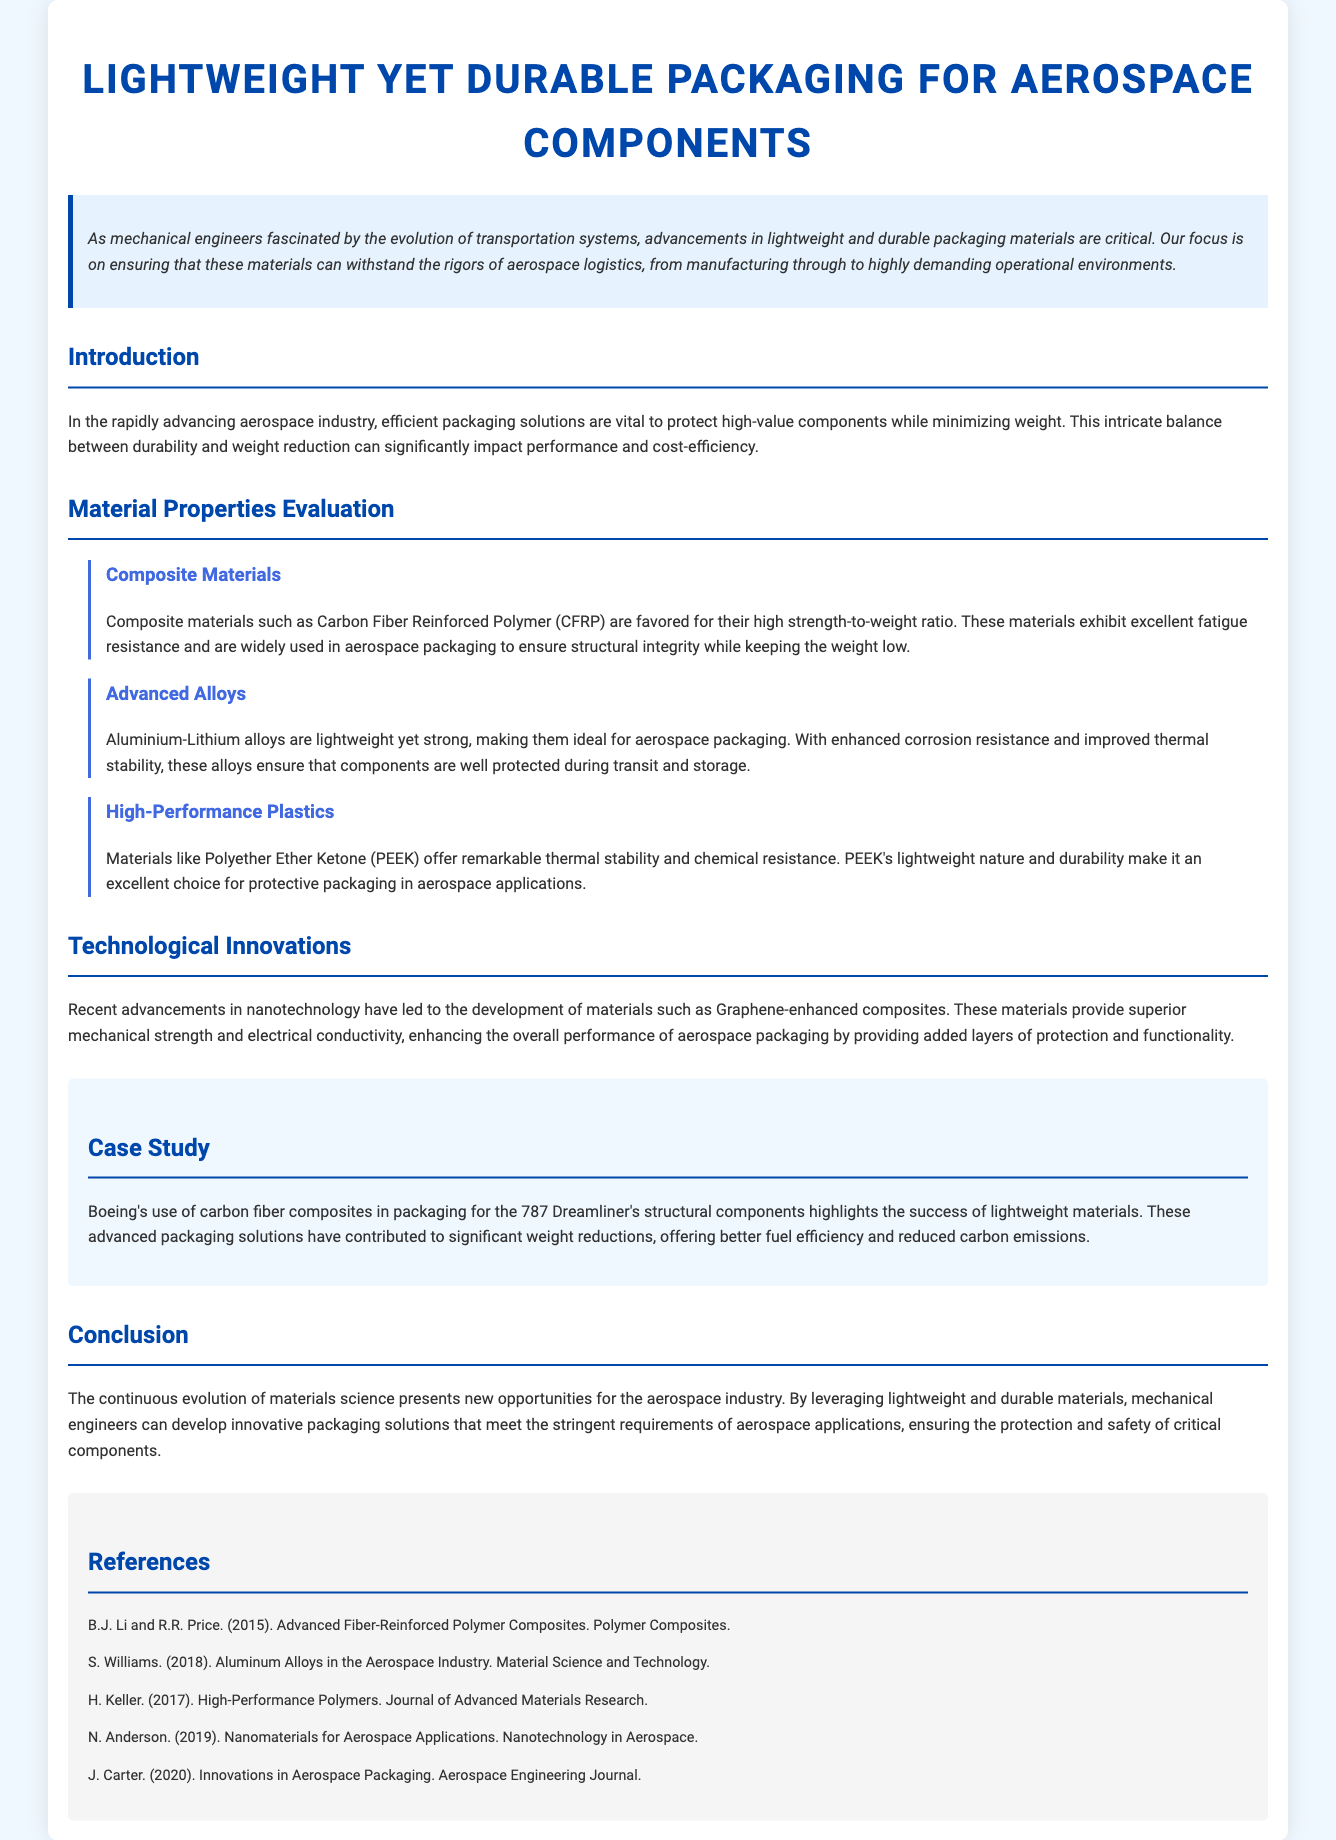what is the title of the document? The title is prominently displayed at the top of the document, providing a clear indication of its content.
Answer: Lightweight yet Durable Packaging for Aerospace Components who authored the case study? The information about the case study identifies Boeing as the entity involved in using innovative packaging solutions.
Answer: Boeing what material is favored for its high strength-to-weight ratio in aerospace packaging? The document specifically mentions the advantages of composite materials, highlighting their benefits for aerospace applications.
Answer: Carbon Fiber Reinforced Polymer (CFRP) what is one technological innovation mentioned in the document? The section on technological innovations discusses recent advancements in materials, specifically highlighting a new type of material.
Answer: Graphene-enhanced composites how many references are listed in the document? The references section lists all the cited works; counting them gives the total number of references.
Answer: Five 